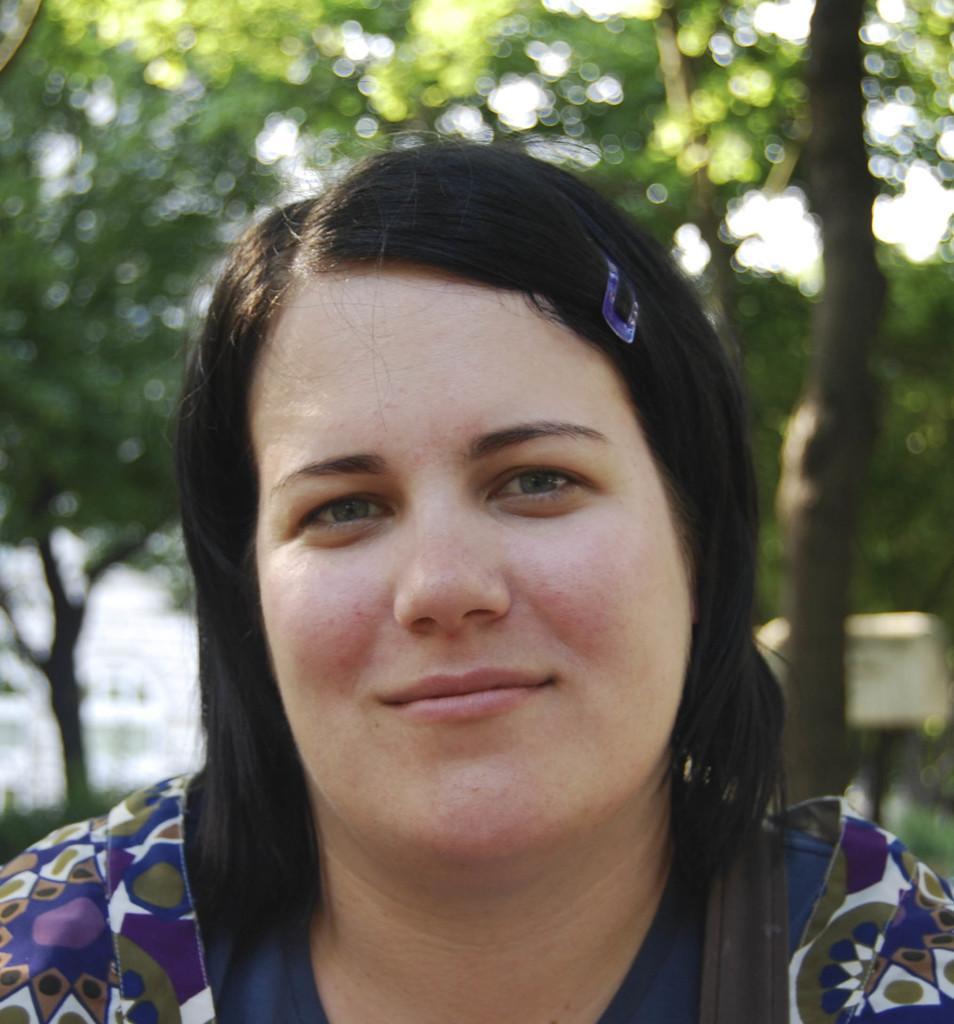Describe this image in one or two sentences. In this image, we can see a woman wearing blue color dress. In the background, we can see trees. 